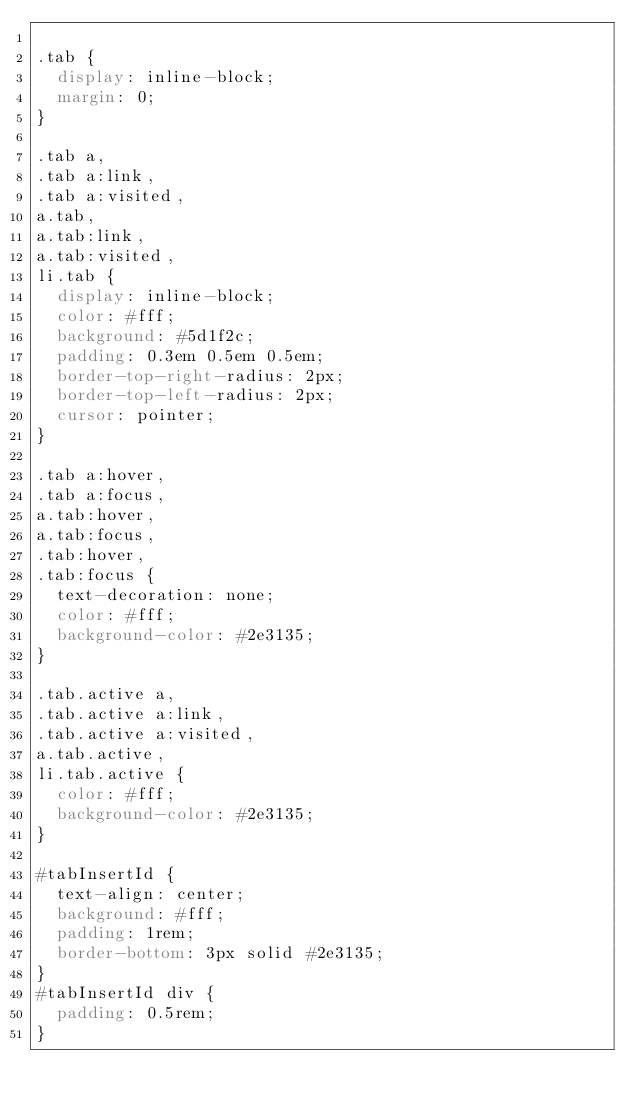<code> <loc_0><loc_0><loc_500><loc_500><_CSS_>
.tab {
  display: inline-block;
  margin: 0;
}

.tab a,
.tab a:link,
.tab a:visited,
a.tab,
a.tab:link,
a.tab:visited,
li.tab {
  display: inline-block;
  color: #fff;
  background: #5d1f2c;
  padding: 0.3em 0.5em 0.5em;
  border-top-right-radius: 2px;
  border-top-left-radius: 2px;
  cursor: pointer;
}

.tab a:hover,
.tab a:focus,
a.tab:hover,
a.tab:focus,
.tab:hover,
.tab:focus {
  text-decoration: none;
  color: #fff;
  background-color: #2e3135;
}

.tab.active a,
.tab.active a:link,
.tab.active a:visited,
a.tab.active,
li.tab.active {
  color: #fff;
  background-color: #2e3135;
}

#tabInsertId {
  text-align: center;
  background: #fff;
  padding: 1rem;
  border-bottom: 3px solid #2e3135;
}
#tabInsertId div {
  padding: 0.5rem;
}
</code> 